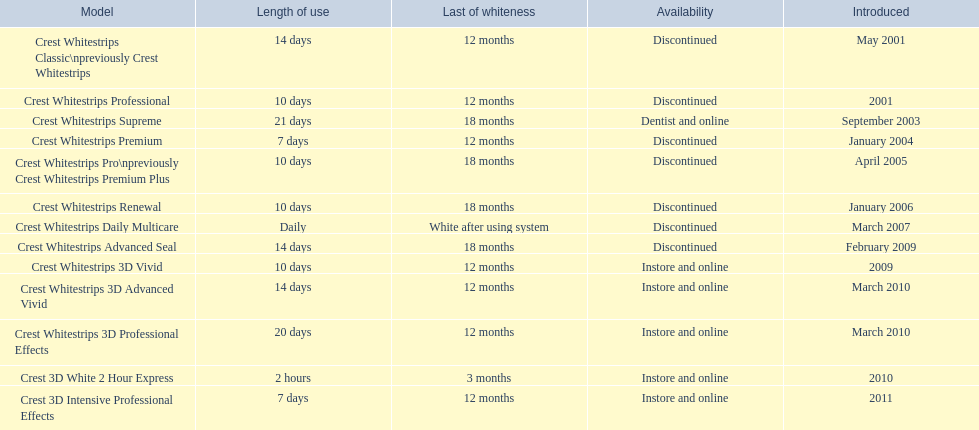When was crest whitestrips 3d advanced vivid introduced? March 2010. What other product was introduced in march 2010? Crest Whitestrips 3D Professional Effects. 